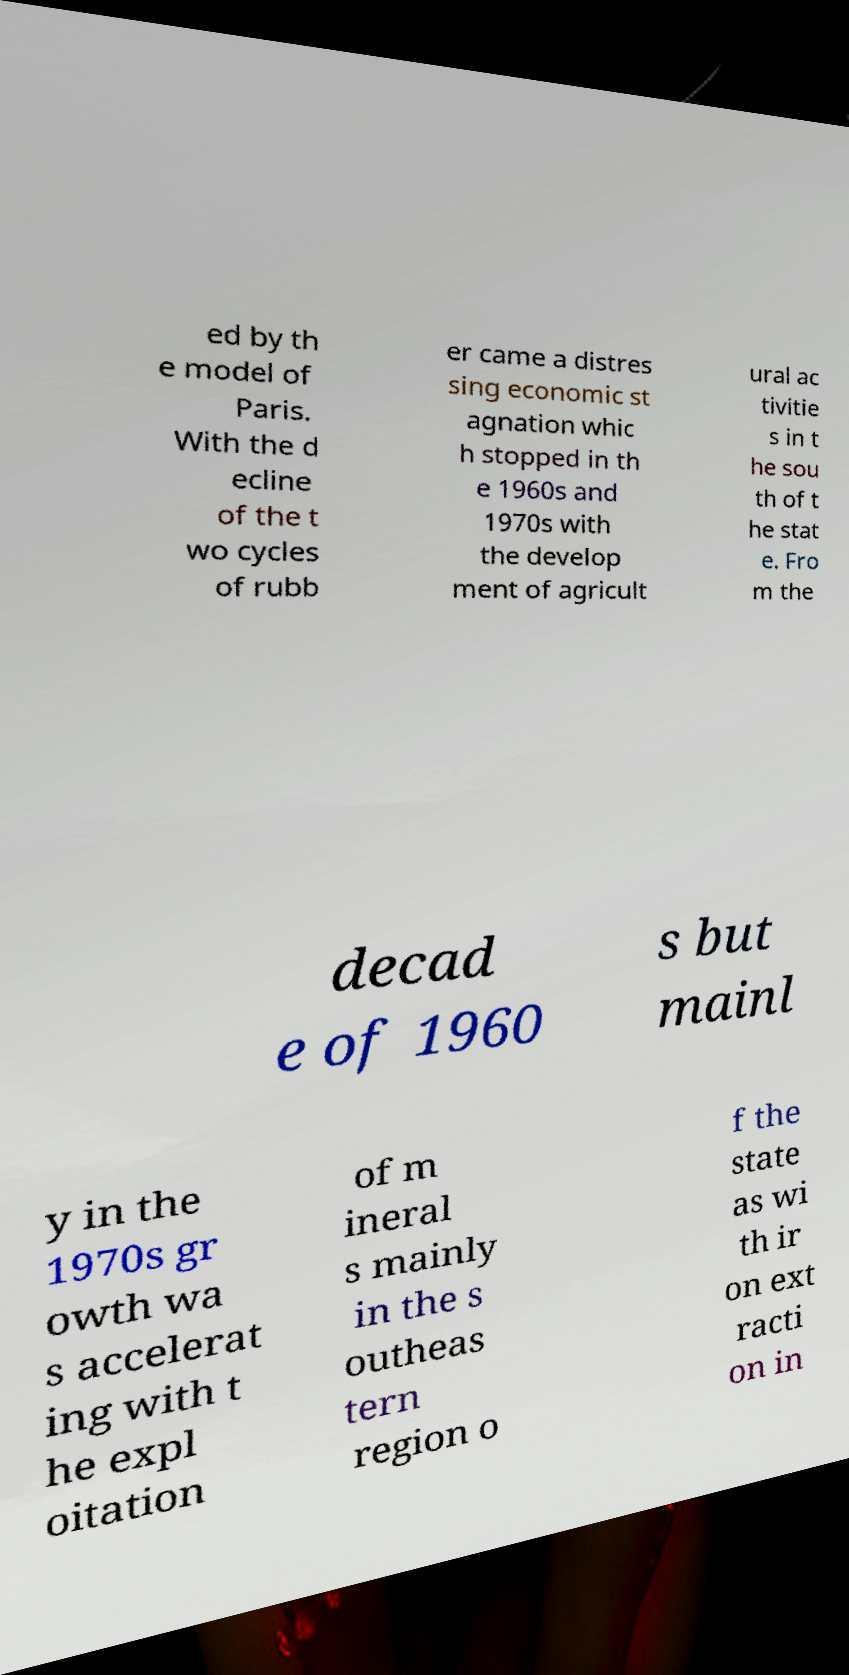There's text embedded in this image that I need extracted. Can you transcribe it verbatim? ed by th e model of Paris. With the d ecline of the t wo cycles of rubb er came a distres sing economic st agnation whic h stopped in th e 1960s and 1970s with the develop ment of agricult ural ac tivitie s in t he sou th of t he stat e. Fro m the decad e of 1960 s but mainl y in the 1970s gr owth wa s accelerat ing with t he expl oitation of m ineral s mainly in the s outheas tern region o f the state as wi th ir on ext racti on in 